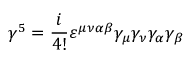<formula> <loc_0><loc_0><loc_500><loc_500>\gamma ^ { 5 } = { \frac { i } { 4 ! } } \varepsilon ^ { \mu \nu \alpha \beta } \gamma _ { \mu } \gamma _ { \nu } \gamma _ { \alpha } \gamma _ { \beta }</formula> 